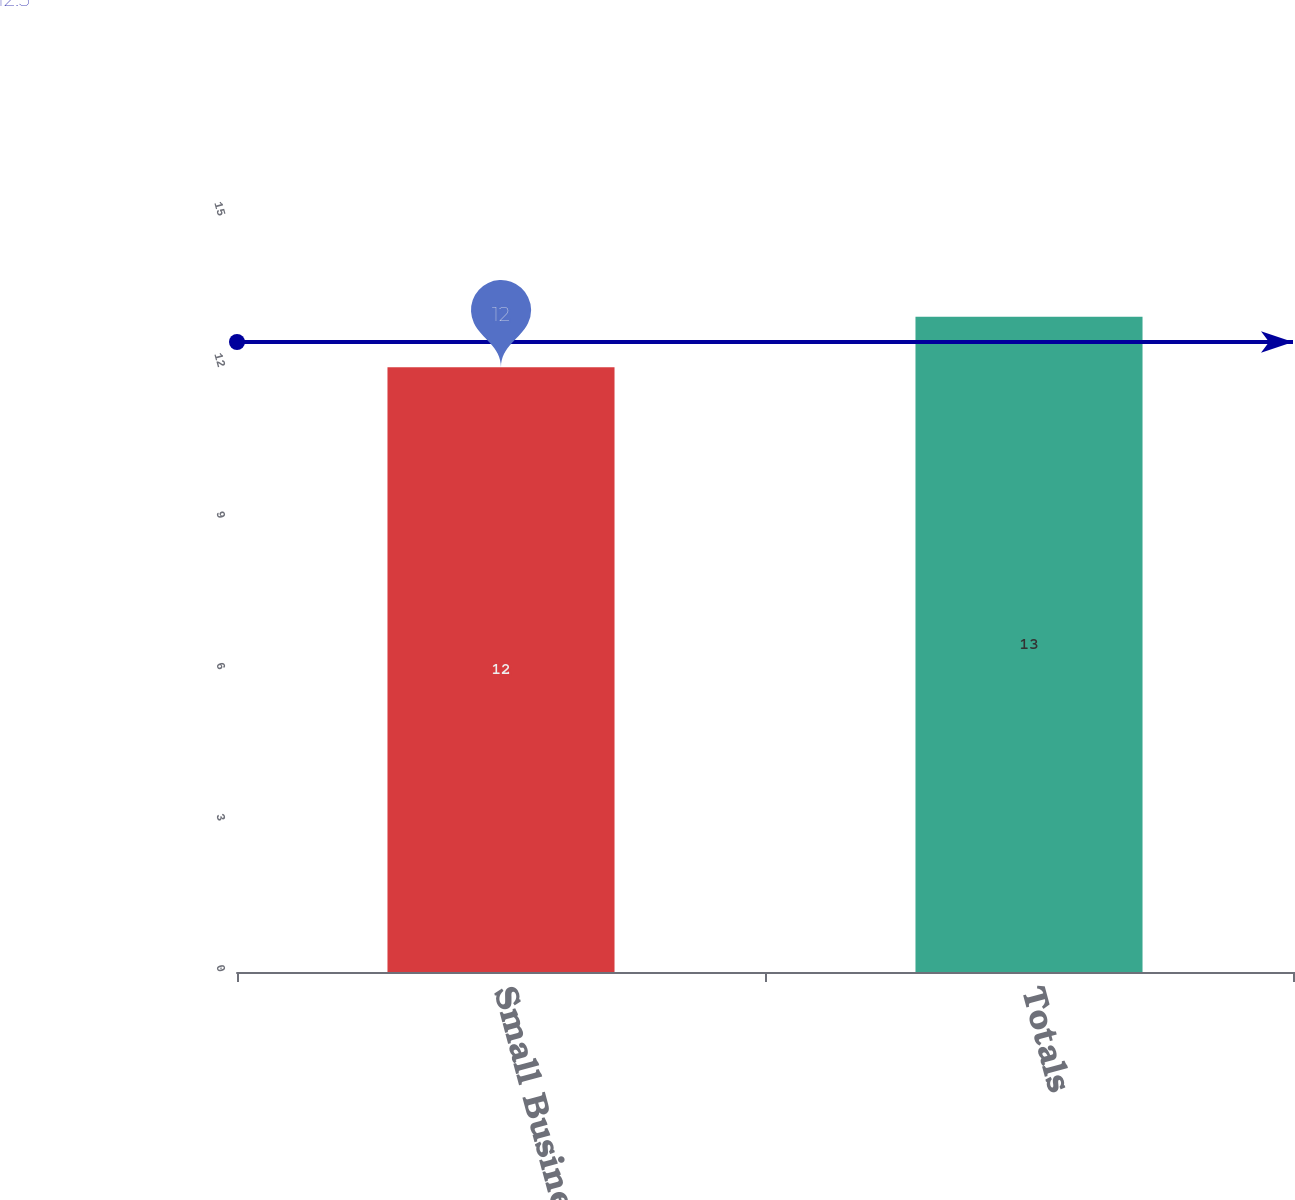Convert chart. <chart><loc_0><loc_0><loc_500><loc_500><bar_chart><fcel>Small Business<fcel>Totals<nl><fcel>12<fcel>13<nl></chart> 